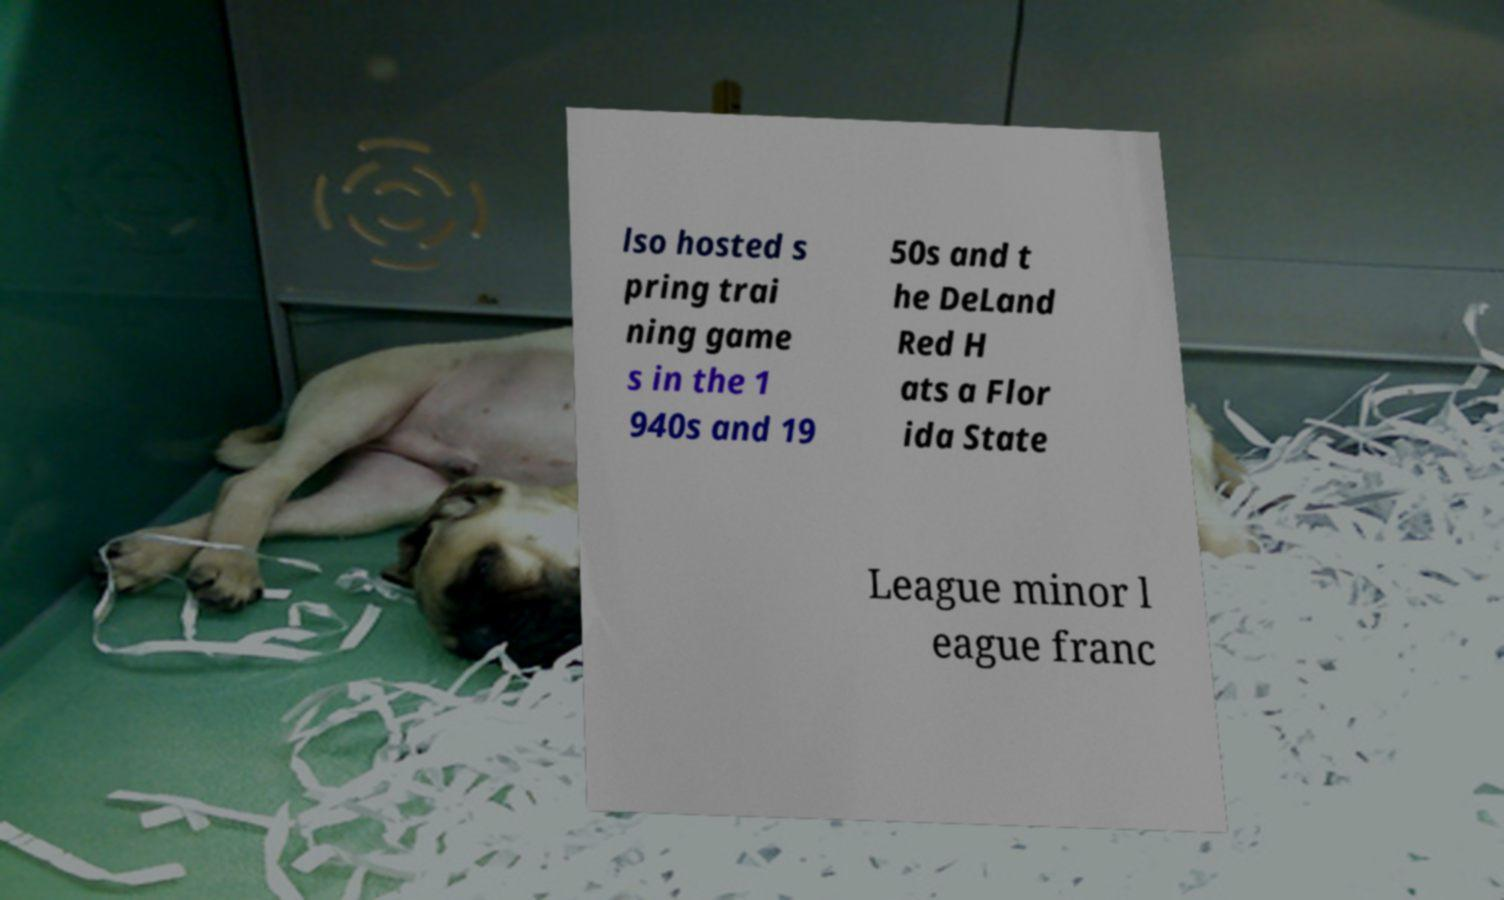Can you read and provide the text displayed in the image?This photo seems to have some interesting text. Can you extract and type it out for me? lso hosted s pring trai ning game s in the 1 940s and 19 50s and t he DeLand Red H ats a Flor ida State League minor l eague franc 